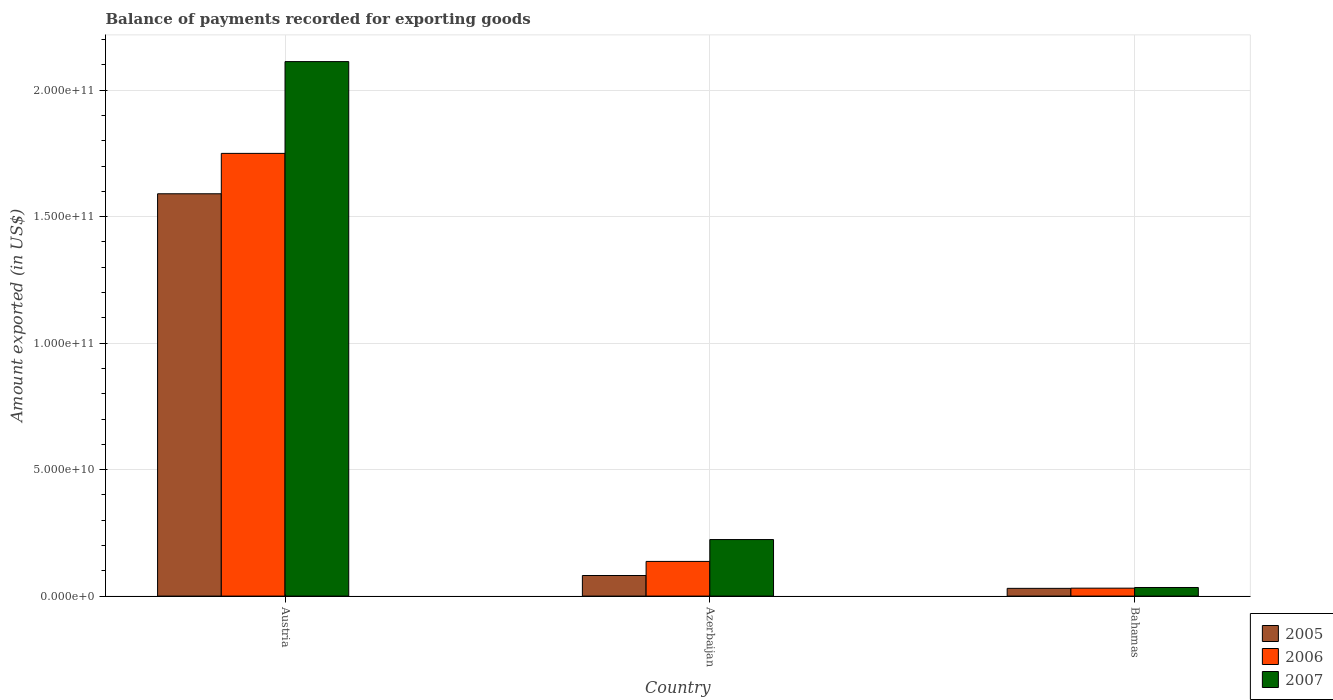Are the number of bars per tick equal to the number of legend labels?
Give a very brief answer. Yes. In how many cases, is the number of bars for a given country not equal to the number of legend labels?
Offer a very short reply. 0. What is the amount exported in 2007 in Azerbaijan?
Provide a short and direct response. 2.24e+1. Across all countries, what is the maximum amount exported in 2006?
Offer a terse response. 1.75e+11. Across all countries, what is the minimum amount exported in 2006?
Offer a terse response. 3.14e+09. In which country was the amount exported in 2005 minimum?
Your response must be concise. Bahamas. What is the total amount exported in 2005 in the graph?
Offer a terse response. 1.70e+11. What is the difference between the amount exported in 2007 in Austria and that in Azerbaijan?
Provide a succinct answer. 1.89e+11. What is the difference between the amount exported in 2005 in Bahamas and the amount exported in 2007 in Azerbaijan?
Your answer should be very brief. -1.93e+1. What is the average amount exported in 2006 per country?
Keep it short and to the point. 6.40e+1. What is the difference between the amount exported of/in 2007 and amount exported of/in 2006 in Austria?
Keep it short and to the point. 3.63e+1. What is the ratio of the amount exported in 2007 in Austria to that in Bahamas?
Offer a very short reply. 62.13. Is the amount exported in 2006 in Austria less than that in Azerbaijan?
Give a very brief answer. No. Is the difference between the amount exported in 2007 in Austria and Azerbaijan greater than the difference between the amount exported in 2006 in Austria and Azerbaijan?
Offer a terse response. Yes. What is the difference between the highest and the second highest amount exported in 2005?
Provide a succinct answer. 1.56e+11. What is the difference between the highest and the lowest amount exported in 2007?
Provide a succinct answer. 2.08e+11. What does the 3rd bar from the left in Austria represents?
Offer a terse response. 2007. What does the 1st bar from the right in Azerbaijan represents?
Your answer should be compact. 2007. Is it the case that in every country, the sum of the amount exported in 2006 and amount exported in 2005 is greater than the amount exported in 2007?
Make the answer very short. No. How many bars are there?
Offer a terse response. 9. Are all the bars in the graph horizontal?
Make the answer very short. No. How many countries are there in the graph?
Make the answer very short. 3. How many legend labels are there?
Provide a succinct answer. 3. What is the title of the graph?
Your response must be concise. Balance of payments recorded for exporting goods. What is the label or title of the X-axis?
Give a very brief answer. Country. What is the label or title of the Y-axis?
Your response must be concise. Amount exported (in US$). What is the Amount exported (in US$) of 2005 in Austria?
Ensure brevity in your answer.  1.59e+11. What is the Amount exported (in US$) of 2006 in Austria?
Provide a succinct answer. 1.75e+11. What is the Amount exported (in US$) of 2007 in Austria?
Offer a terse response. 2.11e+11. What is the Amount exported (in US$) in 2005 in Azerbaijan?
Your answer should be very brief. 8.14e+09. What is the Amount exported (in US$) in 2006 in Azerbaijan?
Offer a very short reply. 1.37e+1. What is the Amount exported (in US$) of 2007 in Azerbaijan?
Give a very brief answer. 2.24e+1. What is the Amount exported (in US$) of 2005 in Bahamas?
Your answer should be compact. 3.06e+09. What is the Amount exported (in US$) of 2006 in Bahamas?
Your answer should be compact. 3.14e+09. What is the Amount exported (in US$) in 2007 in Bahamas?
Keep it short and to the point. 3.40e+09. Across all countries, what is the maximum Amount exported (in US$) in 2005?
Ensure brevity in your answer.  1.59e+11. Across all countries, what is the maximum Amount exported (in US$) of 2006?
Your answer should be compact. 1.75e+11. Across all countries, what is the maximum Amount exported (in US$) in 2007?
Ensure brevity in your answer.  2.11e+11. Across all countries, what is the minimum Amount exported (in US$) in 2005?
Your answer should be very brief. 3.06e+09. Across all countries, what is the minimum Amount exported (in US$) of 2006?
Offer a terse response. 3.14e+09. Across all countries, what is the minimum Amount exported (in US$) of 2007?
Ensure brevity in your answer.  3.40e+09. What is the total Amount exported (in US$) of 2005 in the graph?
Keep it short and to the point. 1.70e+11. What is the total Amount exported (in US$) of 2006 in the graph?
Your answer should be compact. 1.92e+11. What is the total Amount exported (in US$) of 2007 in the graph?
Offer a terse response. 2.37e+11. What is the difference between the Amount exported (in US$) in 2005 in Austria and that in Azerbaijan?
Make the answer very short. 1.51e+11. What is the difference between the Amount exported (in US$) in 2006 in Austria and that in Azerbaijan?
Make the answer very short. 1.61e+11. What is the difference between the Amount exported (in US$) of 2007 in Austria and that in Azerbaijan?
Give a very brief answer. 1.89e+11. What is the difference between the Amount exported (in US$) of 2005 in Austria and that in Bahamas?
Your response must be concise. 1.56e+11. What is the difference between the Amount exported (in US$) of 2006 in Austria and that in Bahamas?
Your answer should be very brief. 1.72e+11. What is the difference between the Amount exported (in US$) of 2007 in Austria and that in Bahamas?
Make the answer very short. 2.08e+11. What is the difference between the Amount exported (in US$) of 2005 in Azerbaijan and that in Bahamas?
Offer a very short reply. 5.08e+09. What is the difference between the Amount exported (in US$) of 2006 in Azerbaijan and that in Bahamas?
Provide a succinct answer. 1.06e+1. What is the difference between the Amount exported (in US$) in 2007 in Azerbaijan and that in Bahamas?
Offer a very short reply. 1.90e+1. What is the difference between the Amount exported (in US$) of 2005 in Austria and the Amount exported (in US$) of 2006 in Azerbaijan?
Make the answer very short. 1.45e+11. What is the difference between the Amount exported (in US$) in 2005 in Austria and the Amount exported (in US$) in 2007 in Azerbaijan?
Give a very brief answer. 1.37e+11. What is the difference between the Amount exported (in US$) of 2006 in Austria and the Amount exported (in US$) of 2007 in Azerbaijan?
Keep it short and to the point. 1.53e+11. What is the difference between the Amount exported (in US$) in 2005 in Austria and the Amount exported (in US$) in 2006 in Bahamas?
Provide a succinct answer. 1.56e+11. What is the difference between the Amount exported (in US$) in 2005 in Austria and the Amount exported (in US$) in 2007 in Bahamas?
Keep it short and to the point. 1.56e+11. What is the difference between the Amount exported (in US$) in 2006 in Austria and the Amount exported (in US$) in 2007 in Bahamas?
Give a very brief answer. 1.72e+11. What is the difference between the Amount exported (in US$) in 2005 in Azerbaijan and the Amount exported (in US$) in 2006 in Bahamas?
Your answer should be very brief. 5.00e+09. What is the difference between the Amount exported (in US$) in 2005 in Azerbaijan and the Amount exported (in US$) in 2007 in Bahamas?
Make the answer very short. 4.74e+09. What is the difference between the Amount exported (in US$) of 2006 in Azerbaijan and the Amount exported (in US$) of 2007 in Bahamas?
Offer a very short reply. 1.03e+1. What is the average Amount exported (in US$) of 2005 per country?
Your response must be concise. 5.68e+1. What is the average Amount exported (in US$) of 2006 per country?
Offer a very short reply. 6.40e+1. What is the average Amount exported (in US$) in 2007 per country?
Ensure brevity in your answer.  7.90e+1. What is the difference between the Amount exported (in US$) in 2005 and Amount exported (in US$) in 2006 in Austria?
Your answer should be very brief. -1.60e+1. What is the difference between the Amount exported (in US$) of 2005 and Amount exported (in US$) of 2007 in Austria?
Give a very brief answer. -5.23e+1. What is the difference between the Amount exported (in US$) in 2006 and Amount exported (in US$) in 2007 in Austria?
Make the answer very short. -3.63e+1. What is the difference between the Amount exported (in US$) in 2005 and Amount exported (in US$) in 2006 in Azerbaijan?
Make the answer very short. -5.57e+09. What is the difference between the Amount exported (in US$) in 2005 and Amount exported (in US$) in 2007 in Azerbaijan?
Your answer should be compact. -1.42e+1. What is the difference between the Amount exported (in US$) of 2006 and Amount exported (in US$) of 2007 in Azerbaijan?
Your answer should be compact. -8.64e+09. What is the difference between the Amount exported (in US$) in 2005 and Amount exported (in US$) in 2006 in Bahamas?
Your answer should be compact. -7.96e+07. What is the difference between the Amount exported (in US$) of 2005 and Amount exported (in US$) of 2007 in Bahamas?
Offer a very short reply. -3.41e+08. What is the difference between the Amount exported (in US$) of 2006 and Amount exported (in US$) of 2007 in Bahamas?
Your response must be concise. -2.62e+08. What is the ratio of the Amount exported (in US$) in 2005 in Austria to that in Azerbaijan?
Provide a succinct answer. 19.54. What is the ratio of the Amount exported (in US$) of 2006 in Austria to that in Azerbaijan?
Keep it short and to the point. 12.76. What is the ratio of the Amount exported (in US$) of 2007 in Austria to that in Azerbaijan?
Offer a very short reply. 9.45. What is the ratio of the Amount exported (in US$) in 2005 in Austria to that in Bahamas?
Your response must be concise. 51.98. What is the ratio of the Amount exported (in US$) of 2006 in Austria to that in Bahamas?
Offer a very short reply. 55.75. What is the ratio of the Amount exported (in US$) of 2007 in Austria to that in Bahamas?
Your answer should be compact. 62.13. What is the ratio of the Amount exported (in US$) of 2005 in Azerbaijan to that in Bahamas?
Keep it short and to the point. 2.66. What is the ratio of the Amount exported (in US$) of 2006 in Azerbaijan to that in Bahamas?
Your answer should be compact. 4.37. What is the ratio of the Amount exported (in US$) of 2007 in Azerbaijan to that in Bahamas?
Your answer should be compact. 6.57. What is the difference between the highest and the second highest Amount exported (in US$) of 2005?
Your response must be concise. 1.51e+11. What is the difference between the highest and the second highest Amount exported (in US$) of 2006?
Ensure brevity in your answer.  1.61e+11. What is the difference between the highest and the second highest Amount exported (in US$) of 2007?
Your answer should be compact. 1.89e+11. What is the difference between the highest and the lowest Amount exported (in US$) of 2005?
Your answer should be very brief. 1.56e+11. What is the difference between the highest and the lowest Amount exported (in US$) of 2006?
Ensure brevity in your answer.  1.72e+11. What is the difference between the highest and the lowest Amount exported (in US$) in 2007?
Your response must be concise. 2.08e+11. 